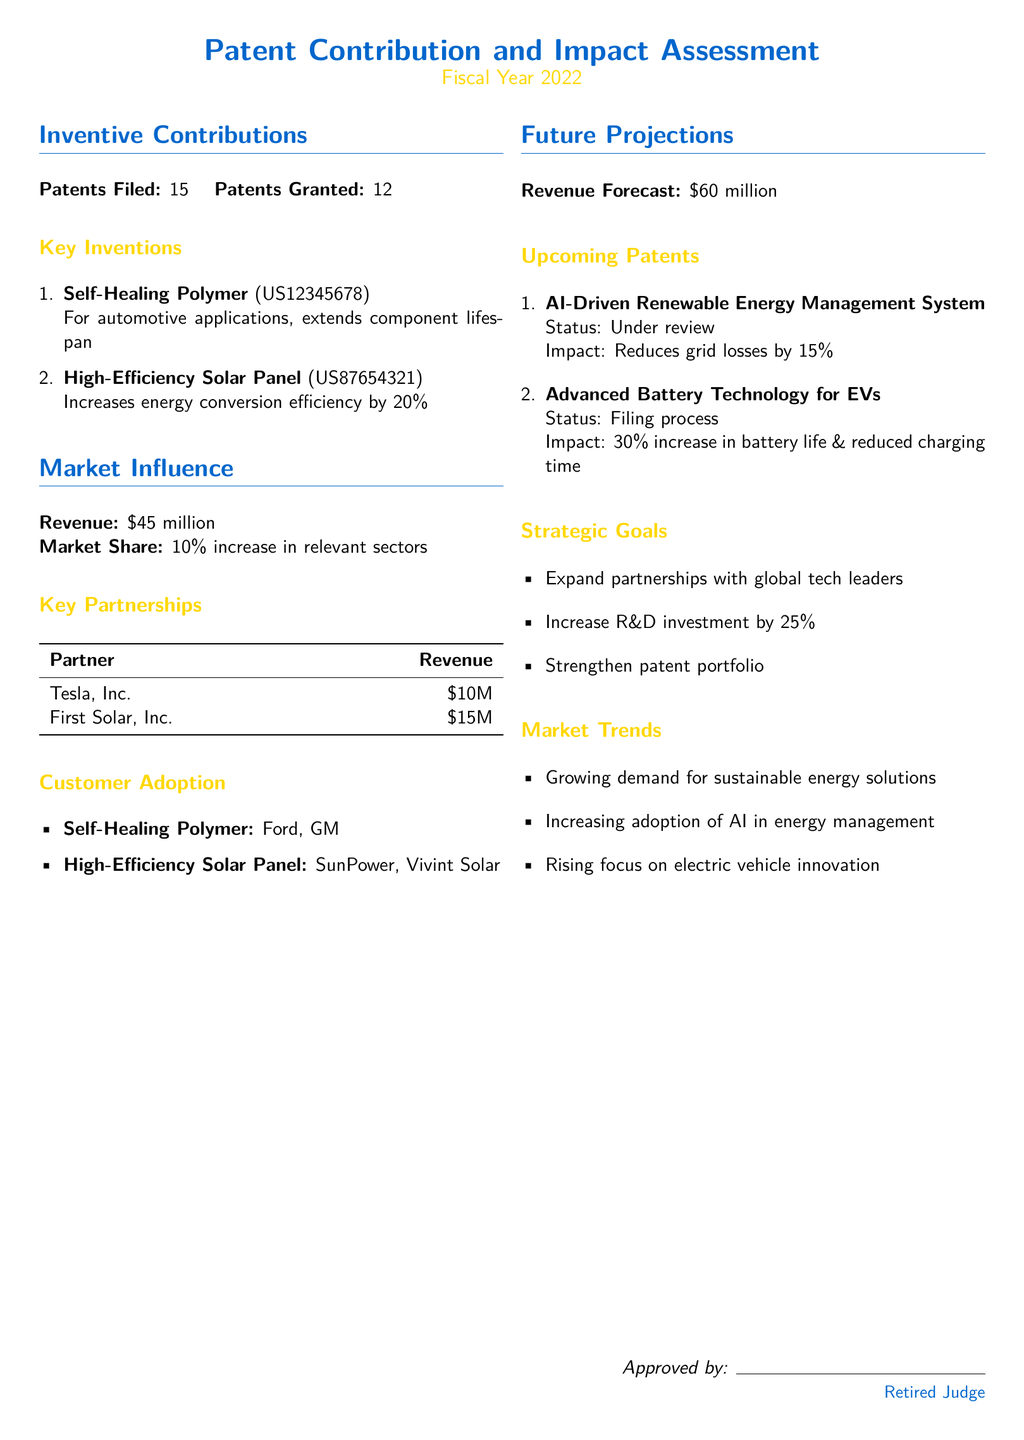What is the number of patents filed? The number of patents filed is stated as 15 in the document.
Answer: 15 What is the revenue for Fiscal Year 2022? The revenue reported in the document for the fiscal year is 45 million dollars.
Answer: 45 million Who are the key partners listed? The document lists Tesla, Inc. and First Solar, Inc. as key partners.
Answer: Tesla, Inc. and First Solar, Inc What is the projected revenue forecast? The revenue forecast for the next fiscal year is outlined as 60 million dollars in the document.
Answer: 60 million What percentage increase in market share is reported? The document reports a 10 percent increase in market share for relevant sectors.
Answer: 10 percent How many patents were granted? The total number of patents granted is mentioned as 12 in the document.
Answer: 12 What is the expected impact of the AI-Driven Renewable Energy Management System? The expected impact of the AI-Driven Renewable Energy Management System is a reduction of grid losses by 15 percent.
Answer: Reduces grid losses by 15 percent What is the strategic goal related to R&D investment? The document states a goal to increase R&D investment by 25 percent.
Answer: Increase R&D investment by 25 percent Which invention focuses on improving battery technology? The invention listed that focuses on improving battery technology is "Advanced Battery Technology for EVs."
Answer: Advanced Battery Technology for EVs 